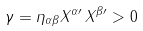<formula> <loc_0><loc_0><loc_500><loc_500>\gamma = \eta _ { \alpha \beta } X ^ { \alpha \prime } \, X ^ { \beta \prime } > 0</formula> 